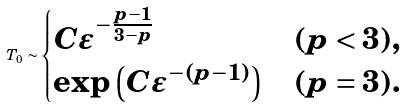<formula> <loc_0><loc_0><loc_500><loc_500>T _ { 0 } \sim \begin{cases} C \varepsilon ^ { - \frac { p - 1 } { 3 - p } } & ( p < 3 ) , \\ \exp \left ( C \varepsilon ^ { - ( p - 1 ) } \right ) & ( p = 3 ) . \end{cases}</formula> 